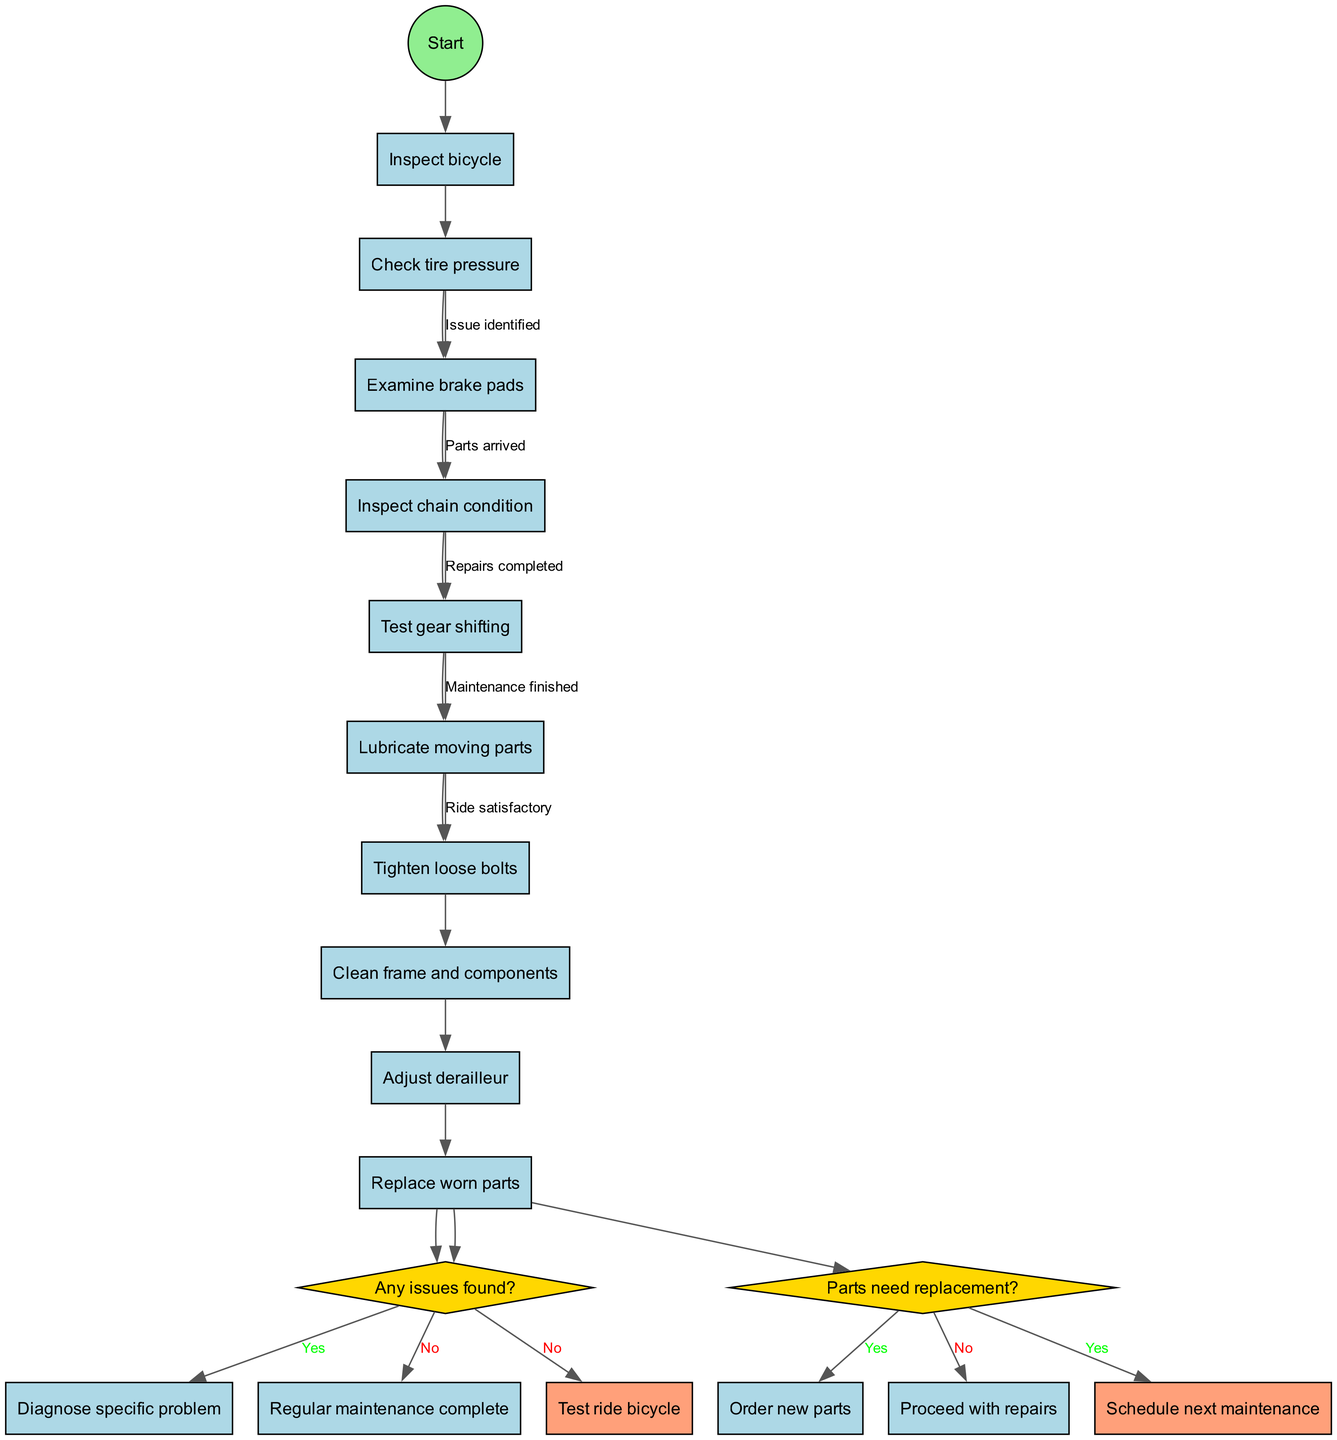What's the initial activity in the diagram? The initial activity listed in the diagram is "Inspect bicycle," which is where the process begins before moving to subsequent activities.
Answer: Inspect bicycle How many main activities are listed in the diagram? By counting the activities in the provided list, there are a total of eight main activities that are related to bicycle maintenance and repairs.
Answer: 8 What decision comes after the last activity? The decision that follows the last activity, "Replace worn parts," is regarding whether any issues were found, which is represented in the diagram.
Answer: Any issues found? What are the final nodes in the diagram? The final nodes include the outcomes after all activities and decisions are completed, specifically "Test ride bicycle" and "Schedule next maintenance."
Answer: Test ride bicycle and Schedule next maintenance If issues are found, what is the next step according to the diagram? If issues are found, the next step is to "Diagnose specific problem," which indicates that addressing the issues takes priority before further maintenance can be done.
Answer: Diagnose specific problem What happens if no parts need replacing after diagnosis? If no parts need replacing, the diagram indicates that the process will proceed with repairs, allowing maintenance to continue without ordering new parts.
Answer: Proceed with repairs How many edges connect the first activity to the decision nodes? The first activity, "Check tire pressure," connects to the first decision (about whether issues were found), resulting in a single edge leading to the decision.
Answer: 1 What happens after successful repairs? Once repairs are completed, the diagram shows that the next step would involve performing a test ride of the bicycle to ensure everything functions properly.
Answer: Test ride bicycle What is the outcome if the ride is satisfactory? If the ride is satisfactory, it indicates that the maintenance process is completed, aligning with scheduling the next maintenance without further immediate actions required.
Answer: Schedule next maintenance 